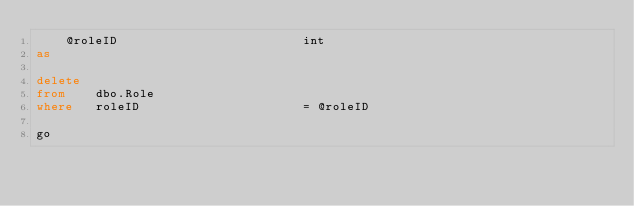<code> <loc_0><loc_0><loc_500><loc_500><_SQL_>	@roleID                         int
as

delete
from	dbo.Role
where	roleID                      = @roleID

go
</code> 